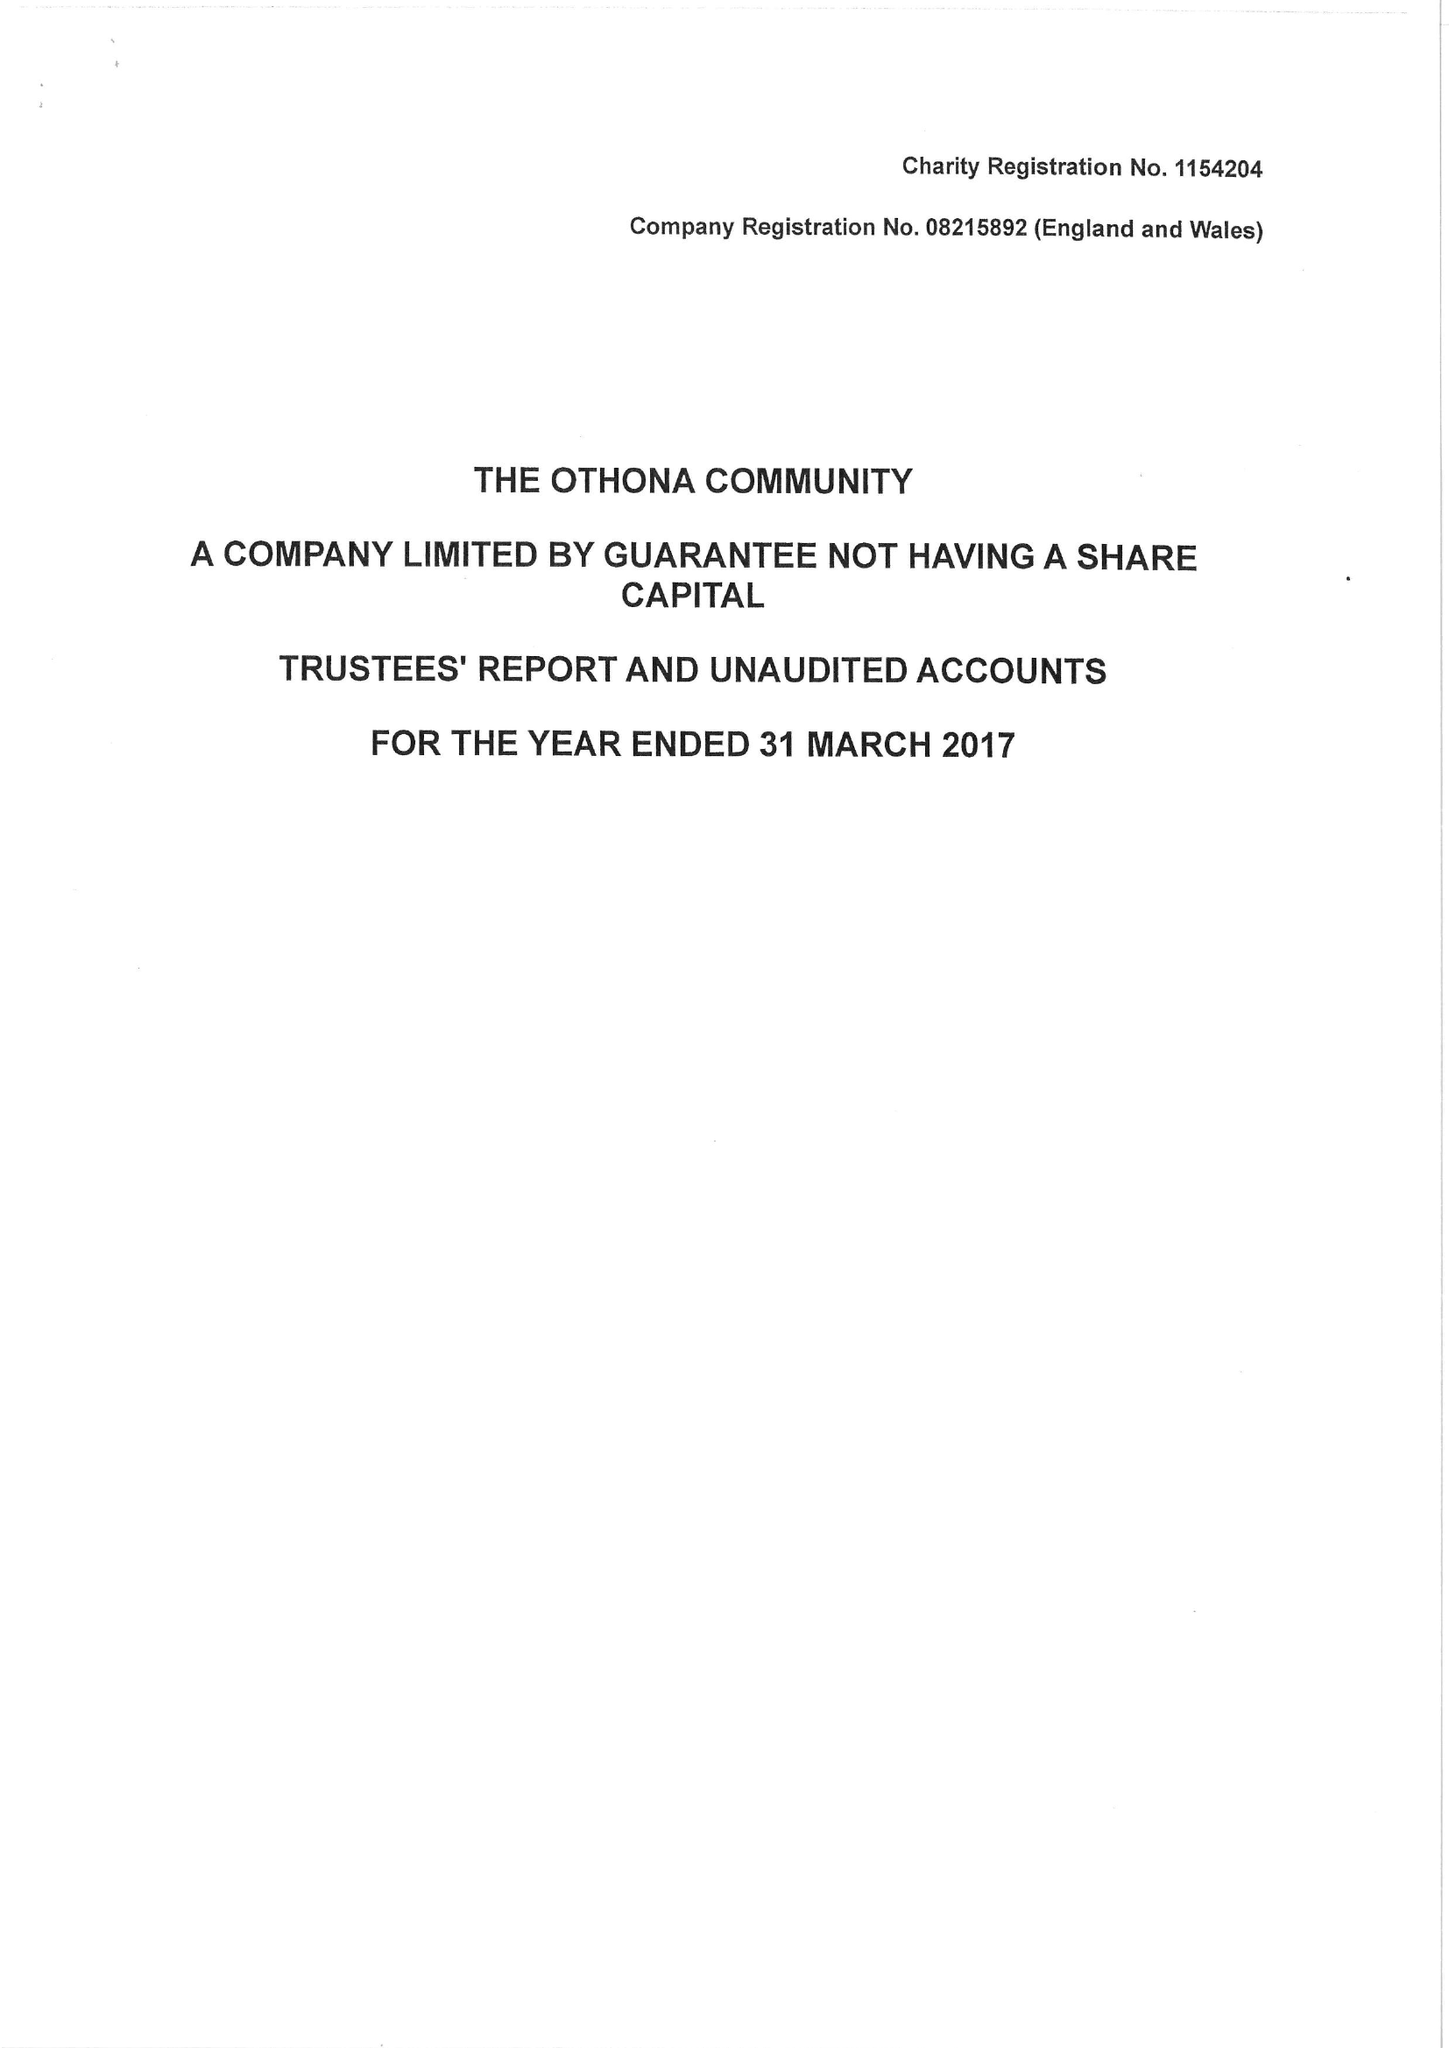What is the value for the address__post_town?
Answer the question using a single word or phrase. SOUTHMINSTER 